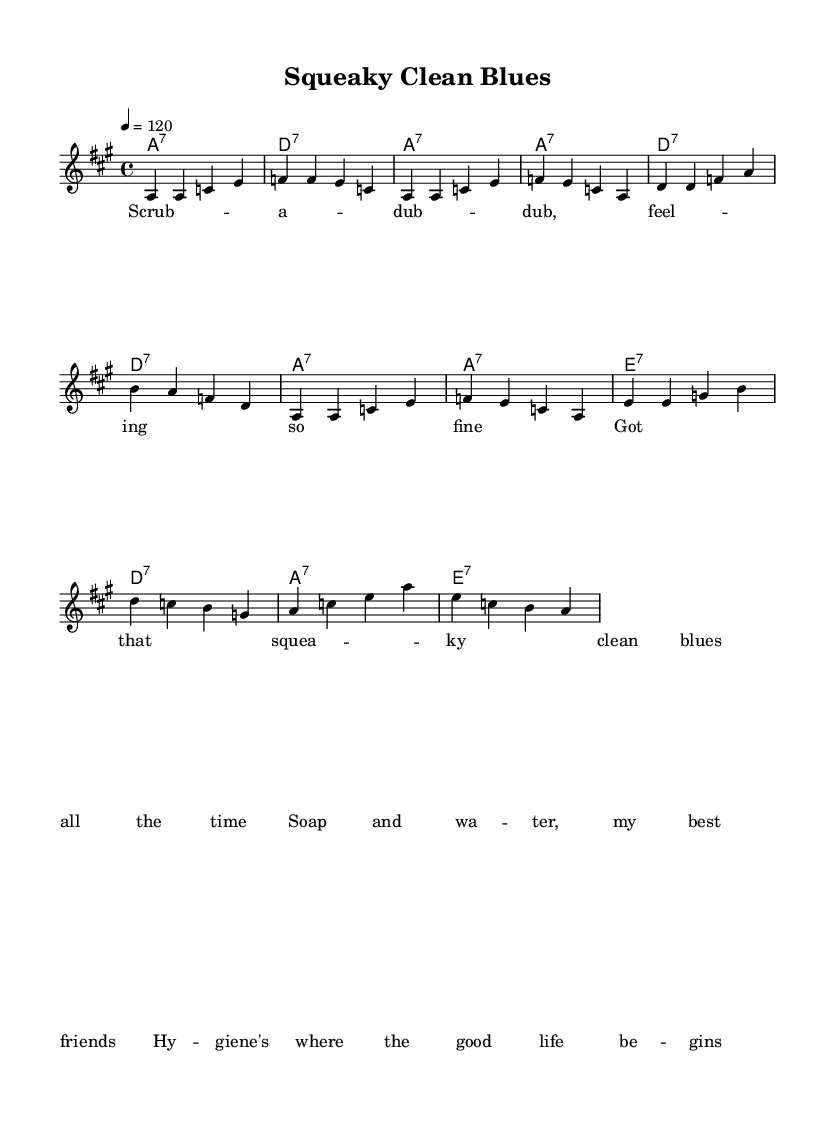What is the key signature of this music? The key signature has three sharps, indicating A major. This can be identified by looking at the key signature at the beginning of the score where the sharps are placed.
Answer: A major What is the time signature of this music? The time signature is indicated right after the key signature, which shows 4/4. This means there are four beats in each measure and the quarter note gets one beat.
Answer: 4/4 What is the tempo marking in this music? The tempo marking is found at the top of the score, stating "4 = 120". This indicates that there are 120 beats per minute, which is a moderate tempo in the context of upbeat electric blues.
Answer: 120 How many measures are in the first verse? Counting the measures in the melodic section of the first verse, there are a total of 8 measures. Each line of the verse corresponds to 4 measures, giving a total of 2 lines.
Answer: 8 What is the mood conveyed by the lyrics? The lyrics describe feelings of cleanliness and comfort, giving off a positive, upbeat vibe that fits the theme of self-care and hygiene. They emphasize a carefree, happy feeling associated with being clean.
Answer: Positive What type of chord progression is primarily used in this piece? The chord progression follows a 12-bar blues structure with a combination of dominant seventh chords that are commonly found in electric blues music, enhancing its characteristic sound.
Answer: 12-bar blues What do the lyrics suggest about the importance of hygiene? The lyrics suggest that hygiene is essential for a good life, as indicated by lines mentioning "soap and water" as best friends, emphasizing self-care and cleanliness.
Answer: Essential 